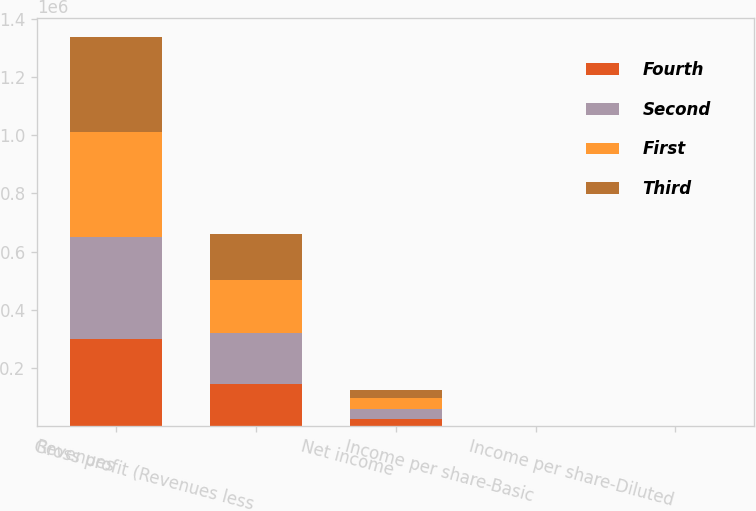Convert chart. <chart><loc_0><loc_0><loc_500><loc_500><stacked_bar_chart><ecel><fcel>Revenues<fcel>Gross profit (Revenues less<fcel>Net income<fcel>Income per share-Basic<fcel>Income per share-Diluted<nl><fcel>Fourth<fcel>299714<fcel>144108<fcel>23179<fcel>0.16<fcel>0.16<nl><fcel>Second<fcel>350798<fcel>176437<fcel>35994<fcel>0.25<fcel>0.25<nl><fcel>First<fcel>362155<fcel>181020<fcel>36200<fcel>0.25<fcel>0.25<nl><fcel>Third<fcel>324707<fcel>157350<fcel>27957<fcel>0.19<fcel>0.19<nl></chart> 